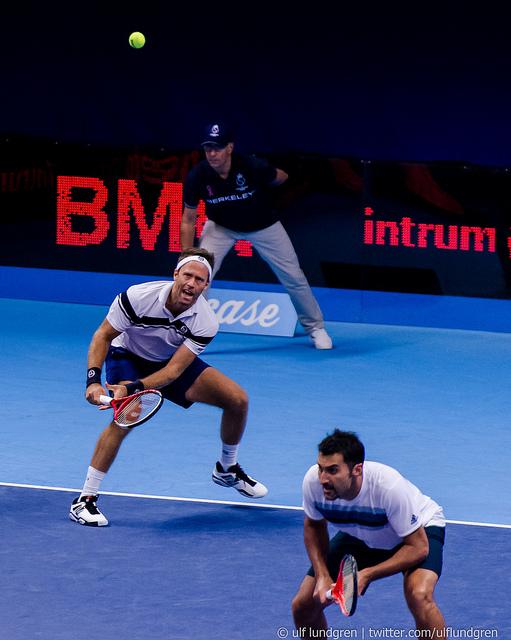How many people are wearing baseball caps?
Be succinct. 1. Who is wearing tan pants?
Quick response, please. Ref. What brand is displayed on the banner behind the player?
Quick response, please. Bmw. Who sponsors this event?
Quick response, please. Bmw. Game played as doubles match with yellow ball?
Short answer required. Tennis. How many feet are shown in this picture?
Concise answer only. 3. What car manufacturer sponsors this sport?
Be succinct. Bmw. 